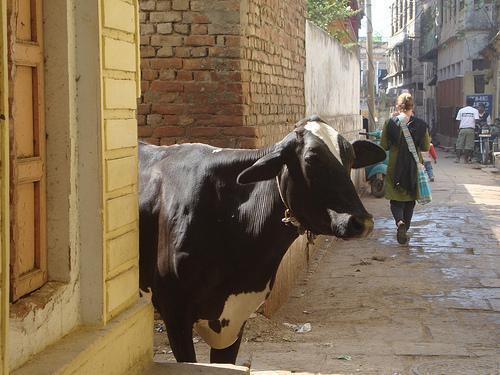How many cows are visible?
Give a very brief answer. 1. 